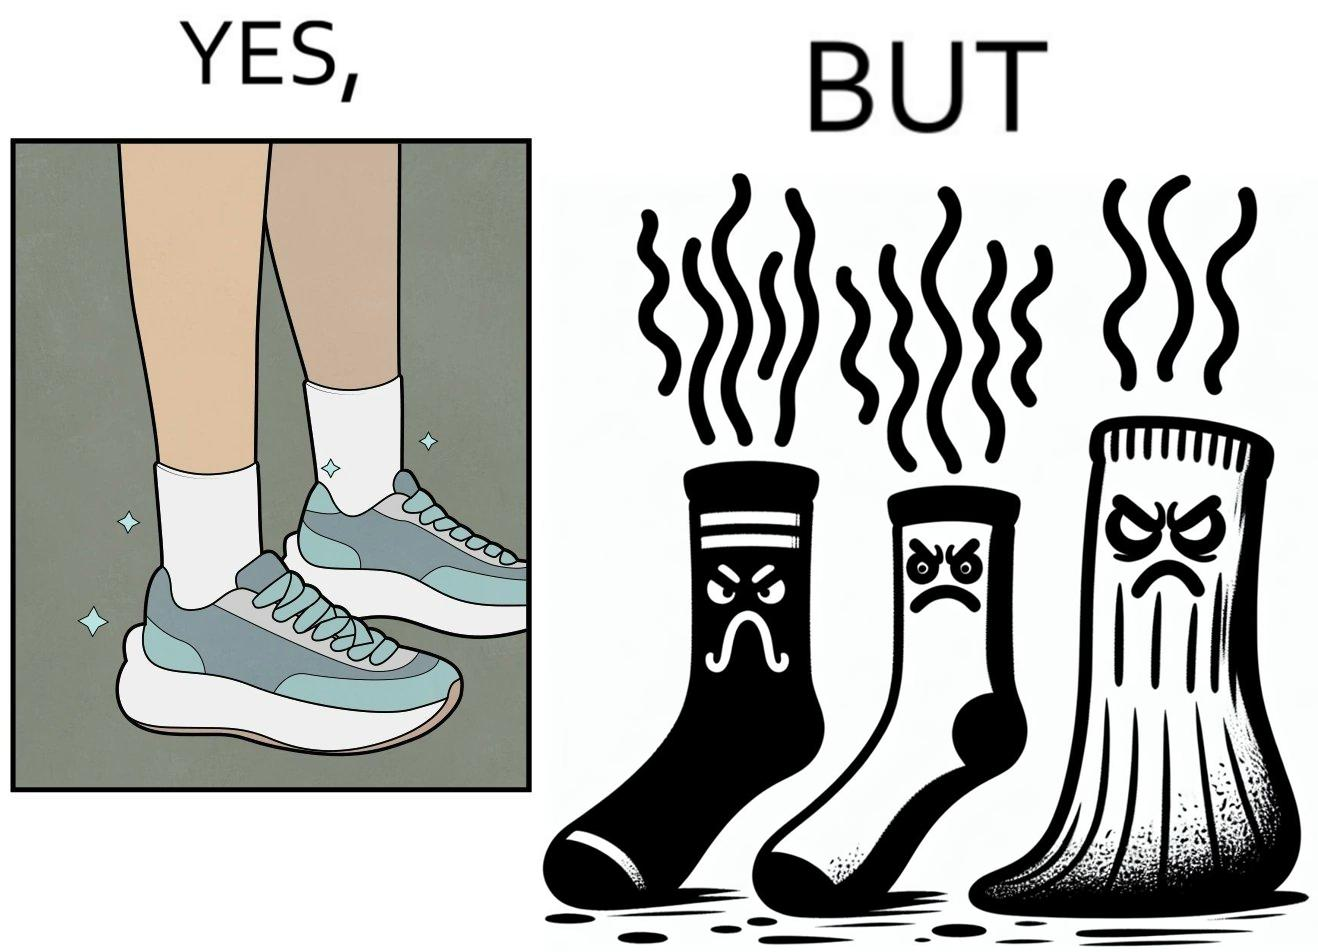Why is this image considered satirical? The person's shocks is very dirty although the shoes are very clean. Thus there is an irony that not all things are same as they appear. 